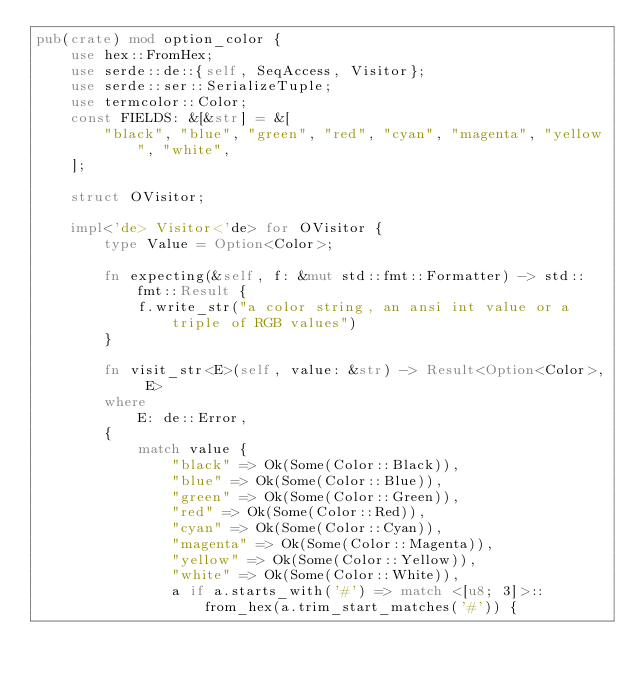Convert code to text. <code><loc_0><loc_0><loc_500><loc_500><_Rust_>pub(crate) mod option_color {
    use hex::FromHex;
    use serde::de::{self, SeqAccess, Visitor};
    use serde::ser::SerializeTuple;
    use termcolor::Color;
    const FIELDS: &[&str] = &[
        "black", "blue", "green", "red", "cyan", "magenta", "yellow", "white",
    ];

    struct OVisitor;

    impl<'de> Visitor<'de> for OVisitor {
        type Value = Option<Color>;

        fn expecting(&self, f: &mut std::fmt::Formatter) -> std::fmt::Result {
            f.write_str("a color string, an ansi int value or a triple of RGB values")
        }

        fn visit_str<E>(self, value: &str) -> Result<Option<Color>, E>
        where
            E: de::Error,
        {
            match value {
                "black" => Ok(Some(Color::Black)),
                "blue" => Ok(Some(Color::Blue)),
                "green" => Ok(Some(Color::Green)),
                "red" => Ok(Some(Color::Red)),
                "cyan" => Ok(Some(Color::Cyan)),
                "magenta" => Ok(Some(Color::Magenta)),
                "yellow" => Ok(Some(Color::Yellow)),
                "white" => Ok(Some(Color::White)),
                a if a.starts_with('#') => match <[u8; 3]>::from_hex(a.trim_start_matches('#')) {</code> 